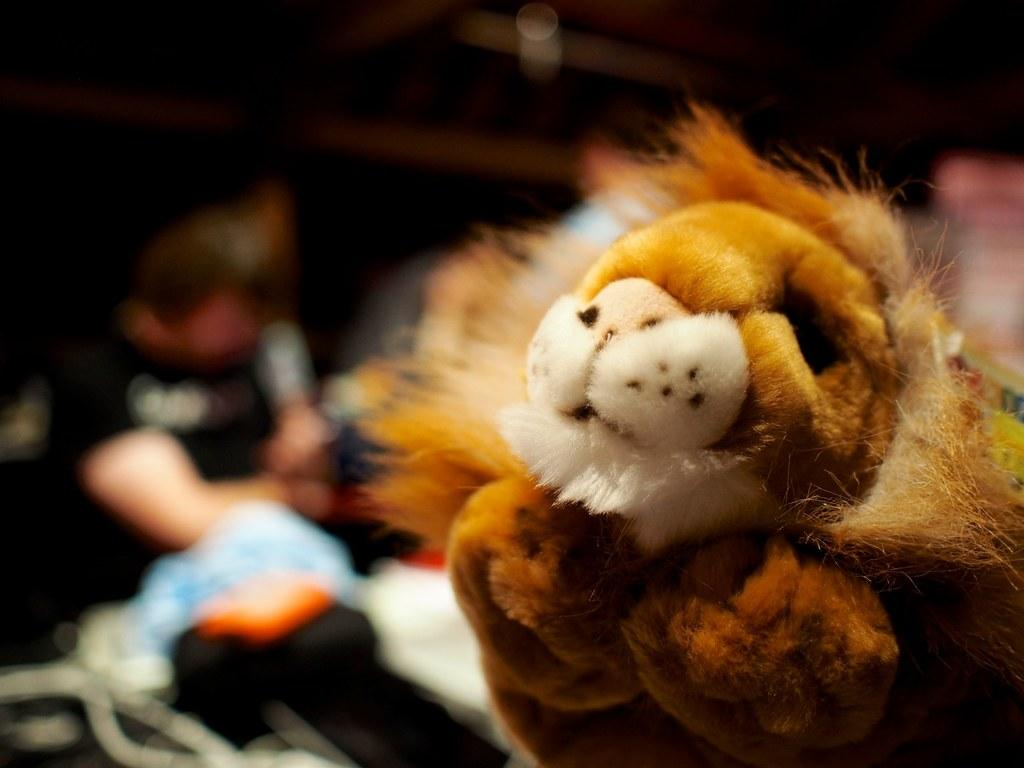What type of object can be seen in the image? There is a soft toy in the image. Can you describe the background of the image? There are objects in the background of the image. What is the current tax rate on the soft toy in the image? There is no information about tax rates in the image, as it only features a soft toy and objects in the background. 